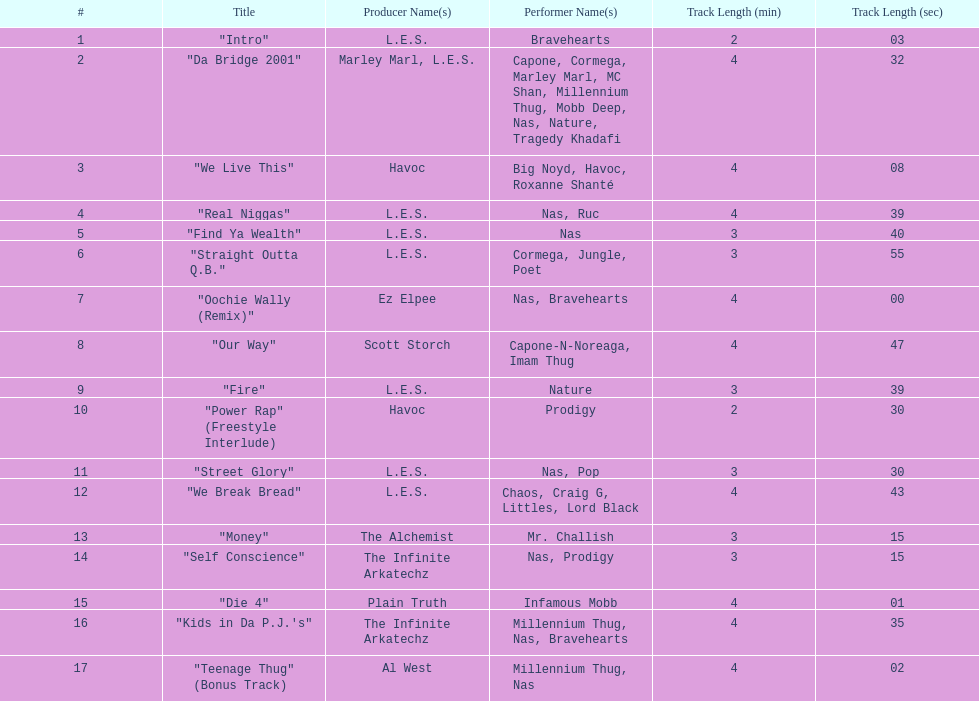How long is the longest track listed? 4:47. 